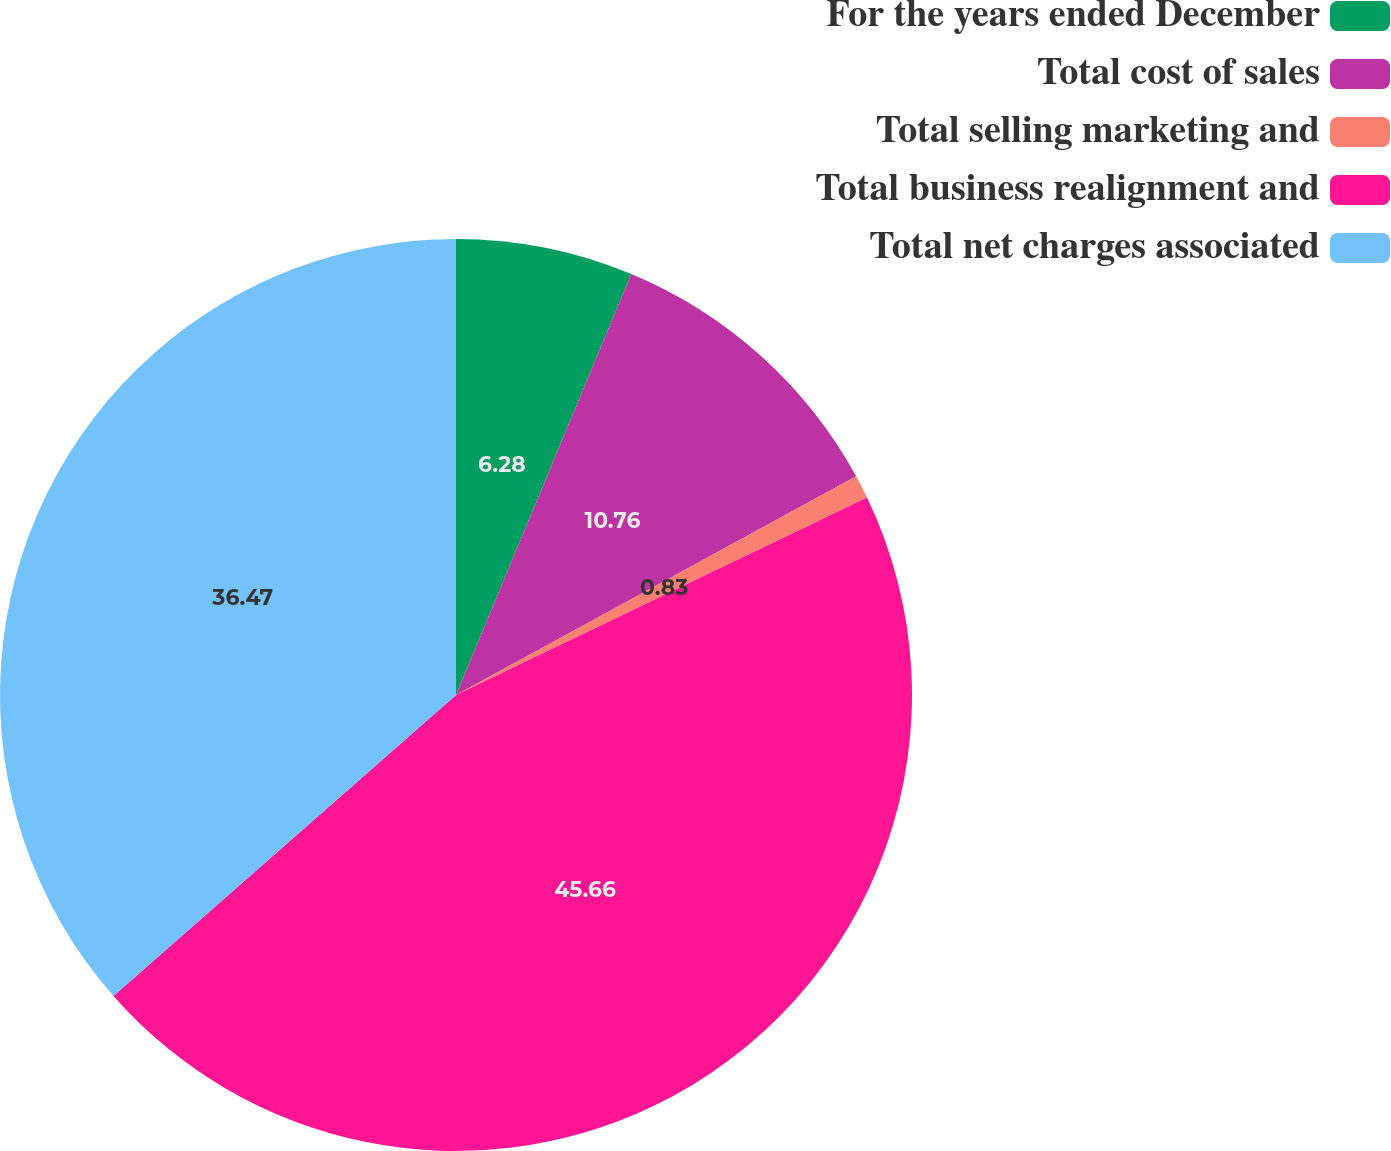Convert chart. <chart><loc_0><loc_0><loc_500><loc_500><pie_chart><fcel>For the years ended December<fcel>Total cost of sales<fcel>Total selling marketing and<fcel>Total business realignment and<fcel>Total net charges associated<nl><fcel>6.28%<fcel>10.76%<fcel>0.83%<fcel>45.65%<fcel>36.47%<nl></chart> 